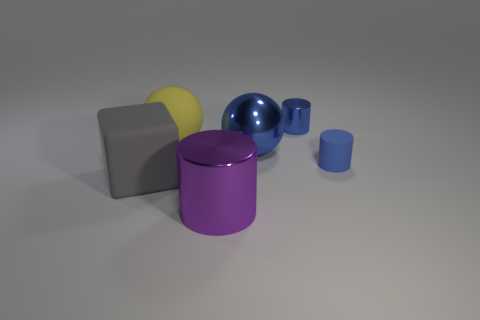What color is the big shiny thing that is in front of the blue rubber object?
Your answer should be compact. Purple. How many other objects are there of the same size as the blue matte thing?
Offer a terse response. 1. Are there any other things that are the same shape as the gray thing?
Your answer should be compact. No. Are there an equal number of cylinders in front of the large yellow thing and small blue cylinders?
Your answer should be compact. Yes. How many small blue things have the same material as the gray object?
Keep it short and to the point. 1. There is a tiny object that is the same material as the large purple object; what is its color?
Provide a succinct answer. Blue. Is the tiny metallic thing the same shape as the tiny blue matte thing?
Your answer should be compact. Yes. There is a rubber object to the left of the ball left of the big cylinder; is there a blue cylinder behind it?
Offer a very short reply. Yes. What number of big shiny spheres have the same color as the rubber cylinder?
Your answer should be very brief. 1. The blue thing that is the same size as the gray object is what shape?
Offer a very short reply. Sphere. 